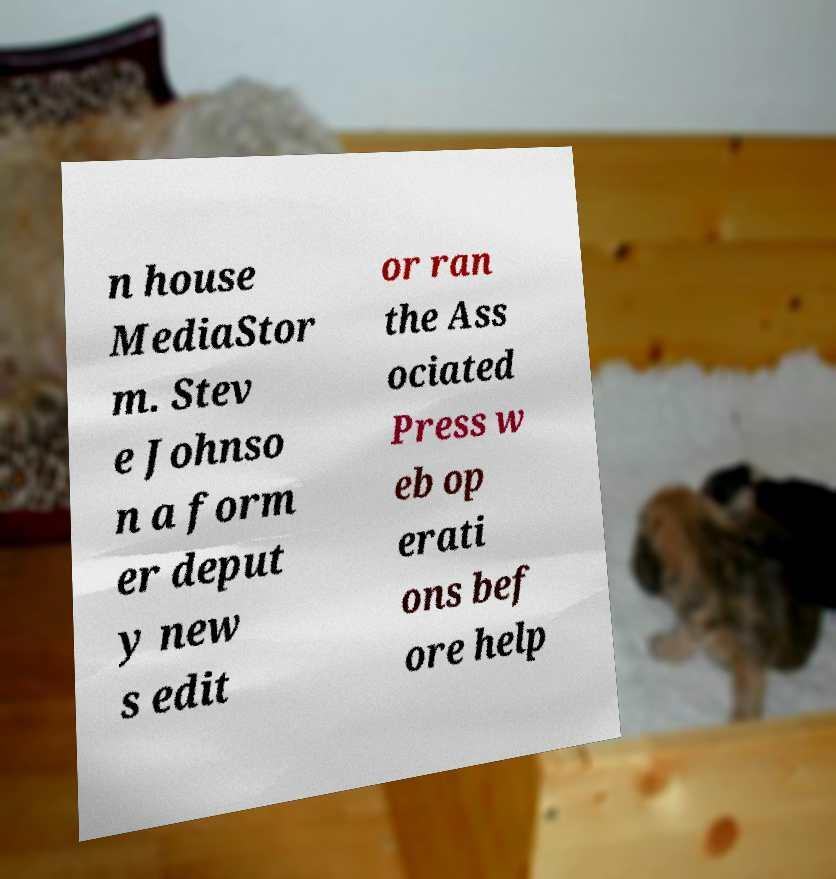I need the written content from this picture converted into text. Can you do that? n house MediaStor m. Stev e Johnso n a form er deput y new s edit or ran the Ass ociated Press w eb op erati ons bef ore help 